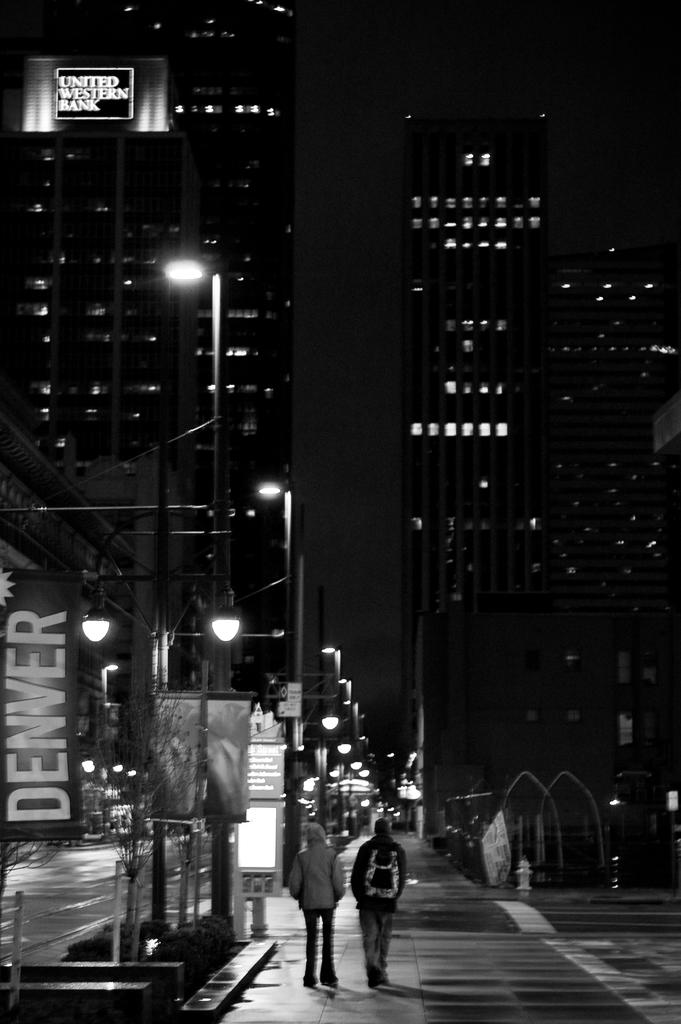What type of structures are visible in the image? There are buildings in the image. What are the two persons at the bottom of the image doing? The two persons are walking at the bottom of the image. What objects can be seen supporting something in the image? There are poles in the image. What can be seen illuminating the area in the image? There are lights in the image. What type of advertisements are present in the image? There are hoardings in the image. What is the color scheme of the image? The image is black and white. How many boys are playing with a rake in the image? There are no boys or rakes present in the image. 